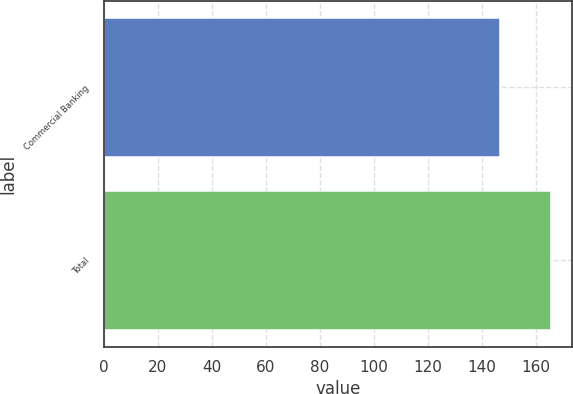Convert chart. <chart><loc_0><loc_0><loc_500><loc_500><bar_chart><fcel>Commercial Banking<fcel>Total<nl><fcel>146.3<fcel>165.3<nl></chart> 